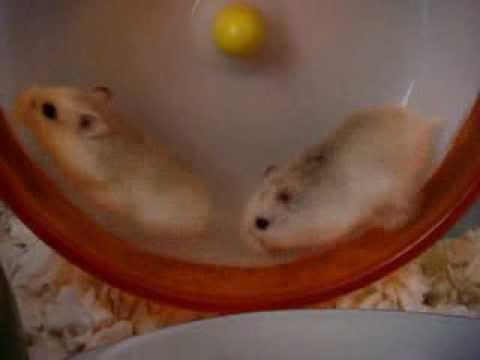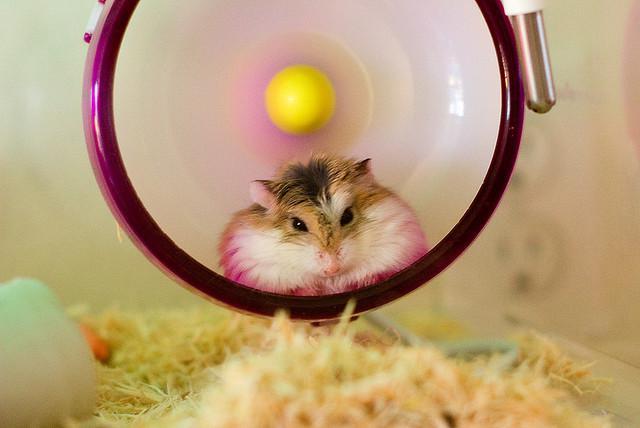The first image is the image on the left, the second image is the image on the right. Given the left and right images, does the statement "One image has two mice running in a hamster wheel." hold true? Answer yes or no. Yes. The first image is the image on the left, the second image is the image on the right. Assess this claim about the two images: "the right image has a hamster in a wheel made of blue metal". Correct or not? Answer yes or no. No. 